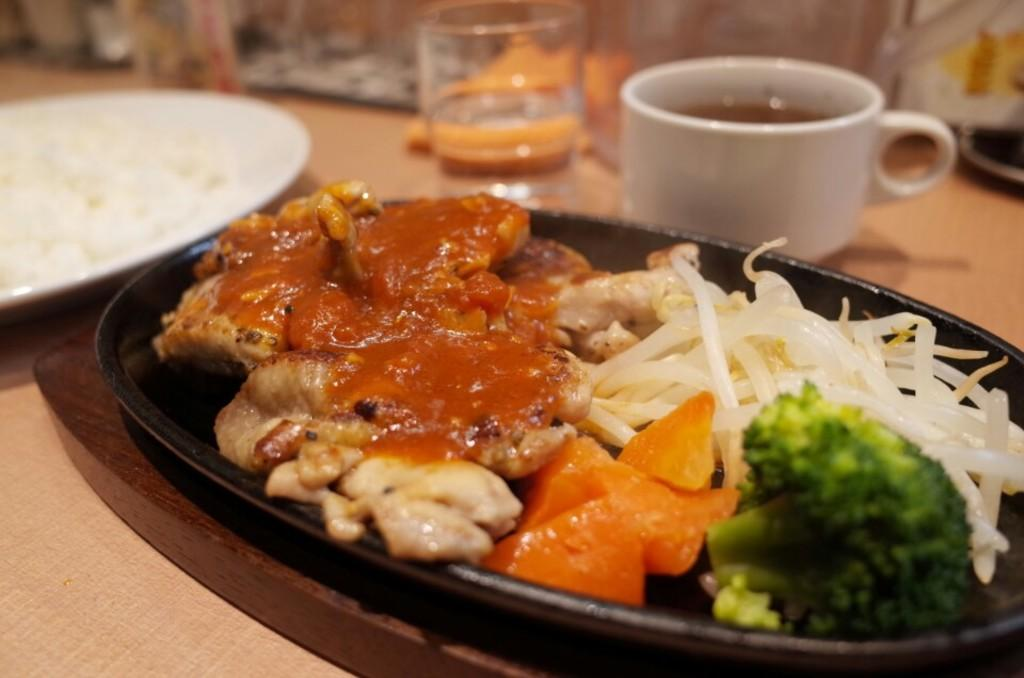What piece of furniture is present in the image? There is a table in the image. What is placed on the table? There are plates on the table. What is in the plates? There is food in the plates. What else is on the table besides plates? There are cups on the table. Can you see a snake slithering across the table in the image? No, there is no snake present in the image. 